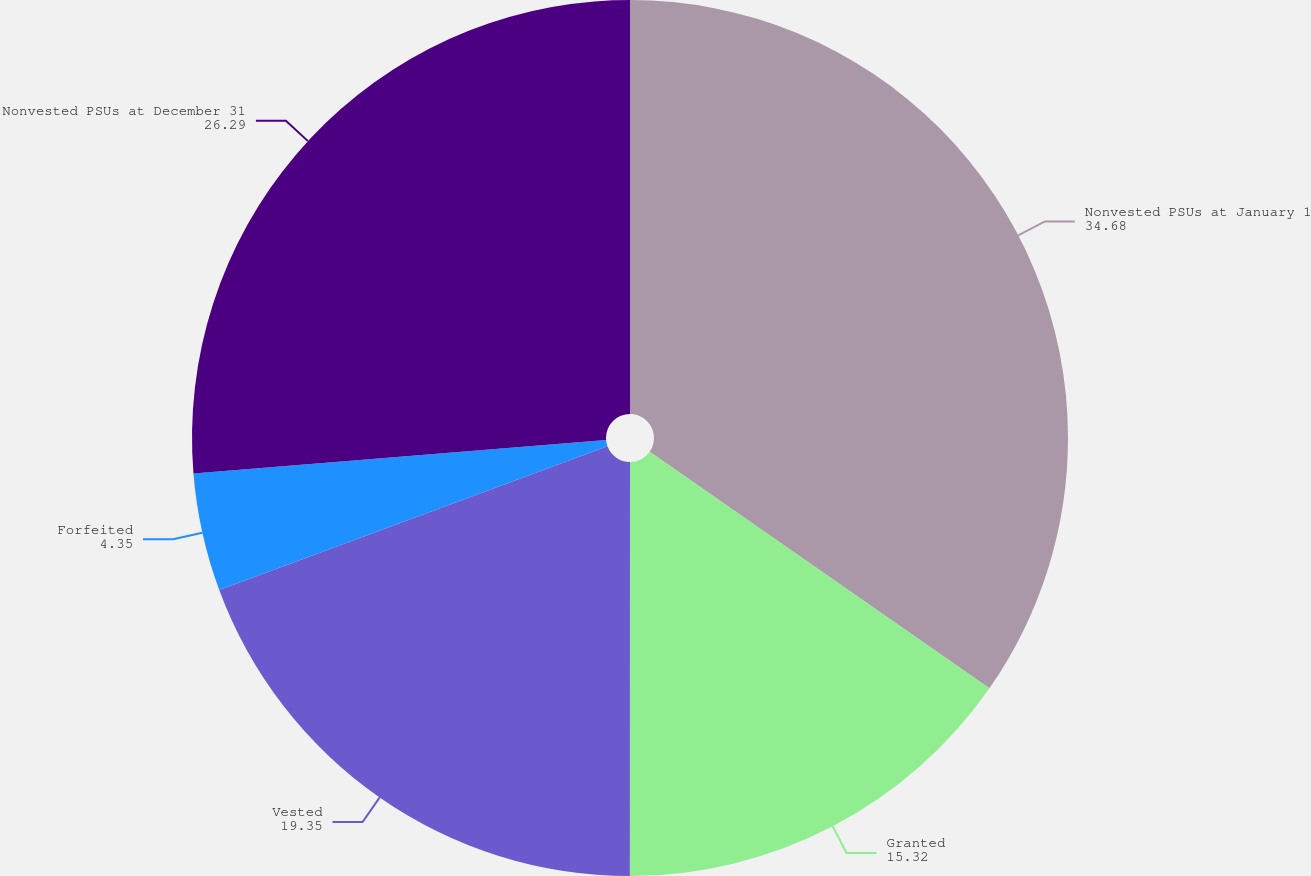Convert chart. <chart><loc_0><loc_0><loc_500><loc_500><pie_chart><fcel>Nonvested PSUs at January 1<fcel>Granted<fcel>Vested<fcel>Forfeited<fcel>Nonvested PSUs at December 31<nl><fcel>34.68%<fcel>15.32%<fcel>19.35%<fcel>4.35%<fcel>26.29%<nl></chart> 